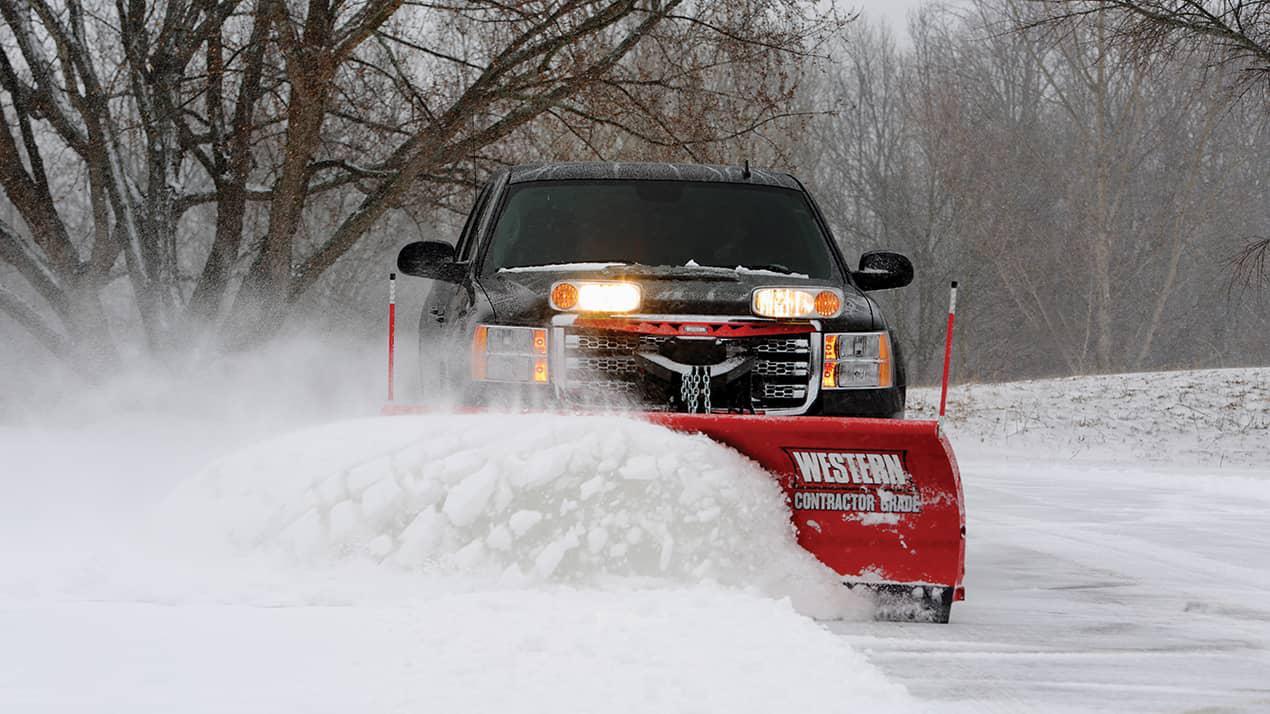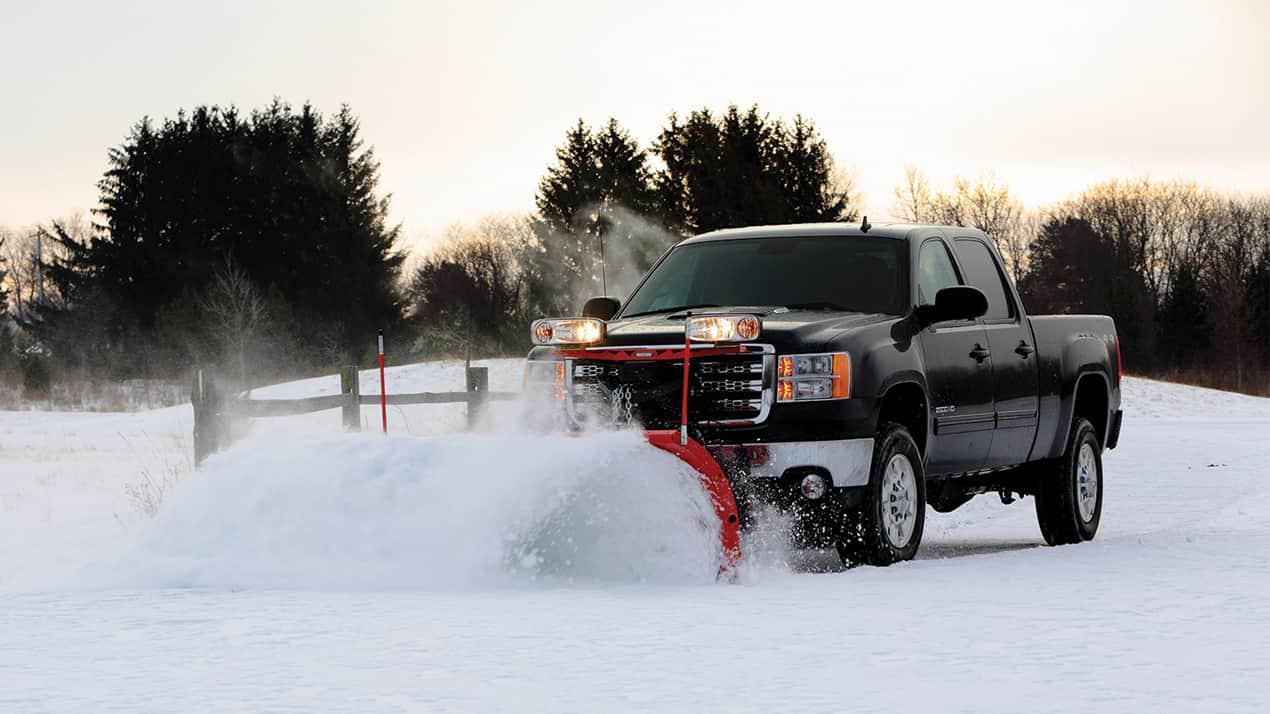The first image is the image on the left, the second image is the image on the right. Assess this claim about the two images: "There are two pick up trucks with a solid colored snow plow attached plowing snow.". Correct or not? Answer yes or no. Yes. 